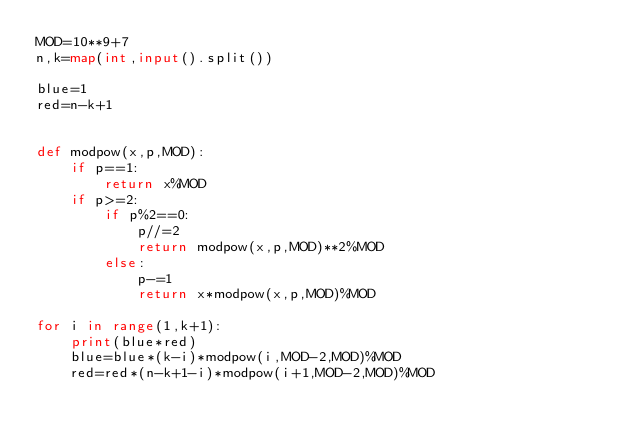<code> <loc_0><loc_0><loc_500><loc_500><_Python_>MOD=10**9+7
n,k=map(int,input().split())
 
blue=1
red=n-k+1


def modpow(x,p,MOD):
    if p==1:
        return x%MOD
    if p>=2:
        if p%2==0:
            p//=2
            return modpow(x,p,MOD)**2%MOD
        else:
            p-=1
            return x*modpow(x,p,MOD)%MOD
 
for i in range(1,k+1):
    print(blue*red)
    blue=blue*(k-i)*modpow(i,MOD-2,MOD)%MOD
    red=red*(n-k+1-i)*modpow(i+1,MOD-2,MOD)%MOD</code> 